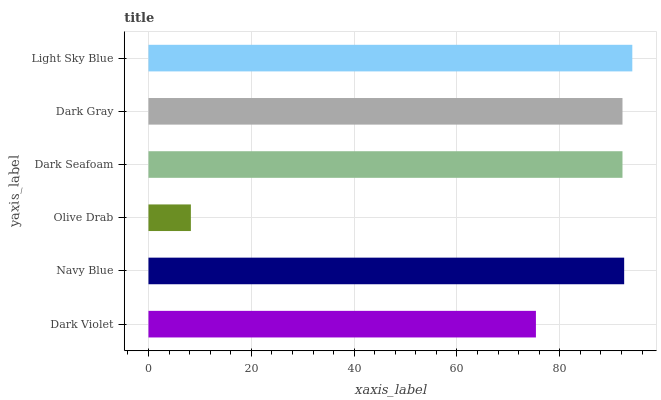Is Olive Drab the minimum?
Answer yes or no. Yes. Is Light Sky Blue the maximum?
Answer yes or no. Yes. Is Navy Blue the minimum?
Answer yes or no. No. Is Navy Blue the maximum?
Answer yes or no. No. Is Navy Blue greater than Dark Violet?
Answer yes or no. Yes. Is Dark Violet less than Navy Blue?
Answer yes or no. Yes. Is Dark Violet greater than Navy Blue?
Answer yes or no. No. Is Navy Blue less than Dark Violet?
Answer yes or no. No. Is Dark Gray the high median?
Answer yes or no. Yes. Is Dark Seafoam the low median?
Answer yes or no. Yes. Is Olive Drab the high median?
Answer yes or no. No. Is Dark Gray the low median?
Answer yes or no. No. 